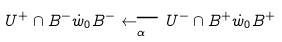Convert formula to latex. <formula><loc_0><loc_0><loc_500><loc_500>U ^ { + } \cap B ^ { - } \dot { w } _ { 0 } B ^ { - } \underset { \alpha } \longleftarrow U ^ { - } \cap B ^ { + } \dot { w } _ { 0 } B ^ { + }</formula> 